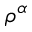Convert formula to latex. <formula><loc_0><loc_0><loc_500><loc_500>\rho ^ { \alpha }</formula> 